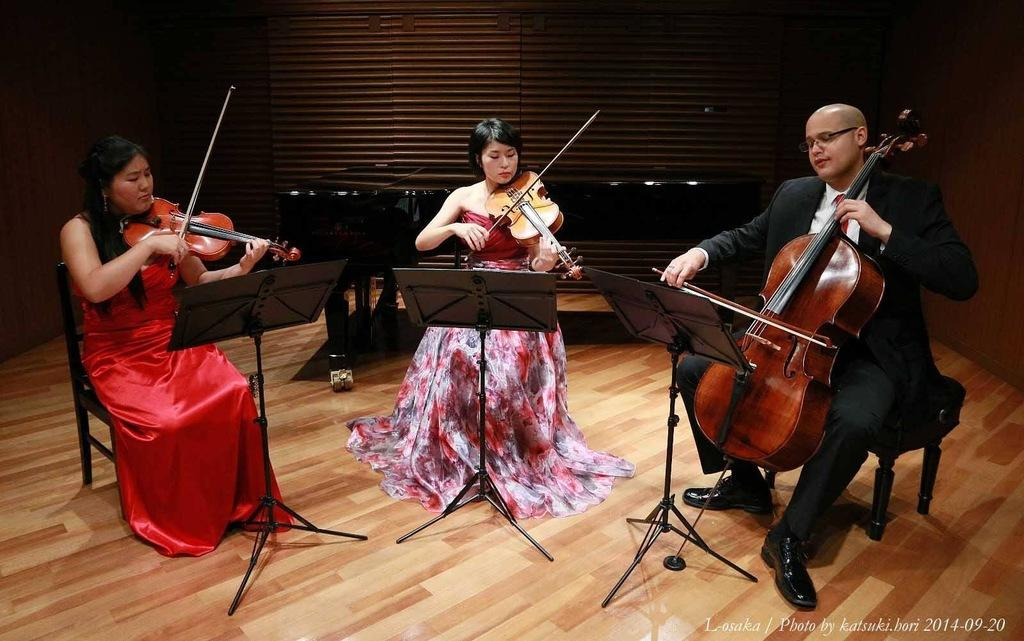How many people are present in the image? There are three people in the image. What are the people doing in the image? The people are playing violins. Can you describe the gender of the individuals in the image? There is one man and two women in the image. How are the people positioned in the image? The three people are sitting on chairs. What type of door can be seen in the image? There is no door present in the image; it features three people playing violins while sitting on chairs. What color is the shirt worn by the spring in the image? There is no spring or shirt present in the image. 